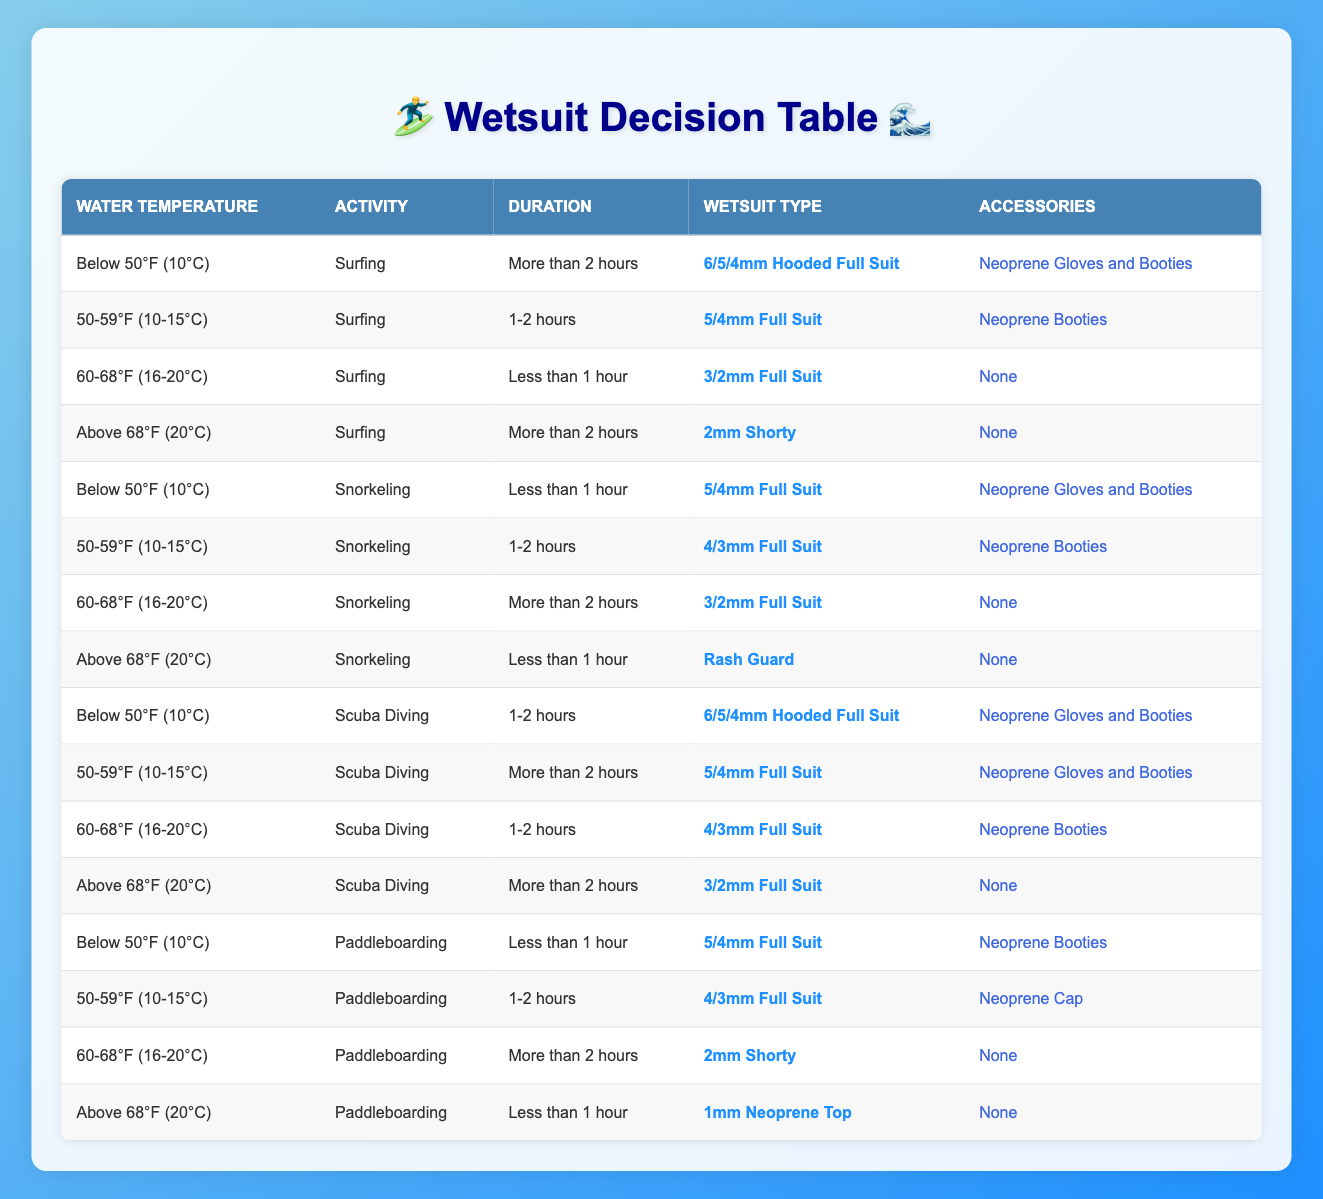What wetsuit type should I choose for surfing in water below 50°F for more than 2 hours? According to the table, if the activity is surfing, the water temperature is below 50°F (10°C), and the duration is more than 2 hours, the recommended wetsuit type is "6/5/4mm Hooded Full Suit."
Answer: 6/5/4mm Hooded Full Suit If I go snorkeling for 1-2 hours in water between 50-59°F, what accessories do I need? Looking at the table, for snorkeling in the 50-59°F (10-15°C) temperature range with a duration of 1-2 hours, you would need "Neoprene Booties" as accessories.
Answer: Neoprene Booties Is a rash guard appropriate for snorkeling in water above 68°F for less than 1 hour? The table indicates that for snorkeling in water above 68°F (20°C) for less than 1 hour, a "Rash Guard" is suitable. Thus this fact is true.
Answer: True What is the recommended wetsuit for scuba diving in water that is 60-68°F for 1-2 hours? The table shows that for scuba diving in the 60-68°F (16-20°C) temperature range and for 1-2 hours, the recommended wetsuit is "4/3mm Full Suit."
Answer: 4/3mm Full Suit Which accessories are needed for paddleboarding for more than 2 hours in water between 60-68°F? For paddleboarding lasting more than 2 hours in water within the 60-68°F (16-20°C) range, the table specifies that no accessories are required. Thus, the answer is none.
Answer: None How many different wetsuit types are recommended for snorkeling at a temperature below 50°F? The table lists 3 different wetsuit types for snorkeling in water below 50°F (10°C): "5/4mm Full Suit" (for less than 1 hour), "4/3mm Full Suit" (for 1-2 hours), and "3/2mm Full Suit" (for more than 2 hours). Therefore, the total count is 3.
Answer: 3 If someone is surfing for less than 1 hour in water above 68°F, what wetsuit should they wear? The table states for surfing for less than 1 hour in water above 68°F (20°C), the wearer needs a "2mm Shorty." Therefore, the answer is clear.
Answer: 2mm Shorty What is the wetsuit type for paddleboarding for less than 1 hour in water below 50°F? According to the table, the wetsuit type recommended for paddleboarding in water below 50°F (10°C) for less than 1 hour is "5/4mm Full Suit."
Answer: 5/4mm Full Suit 